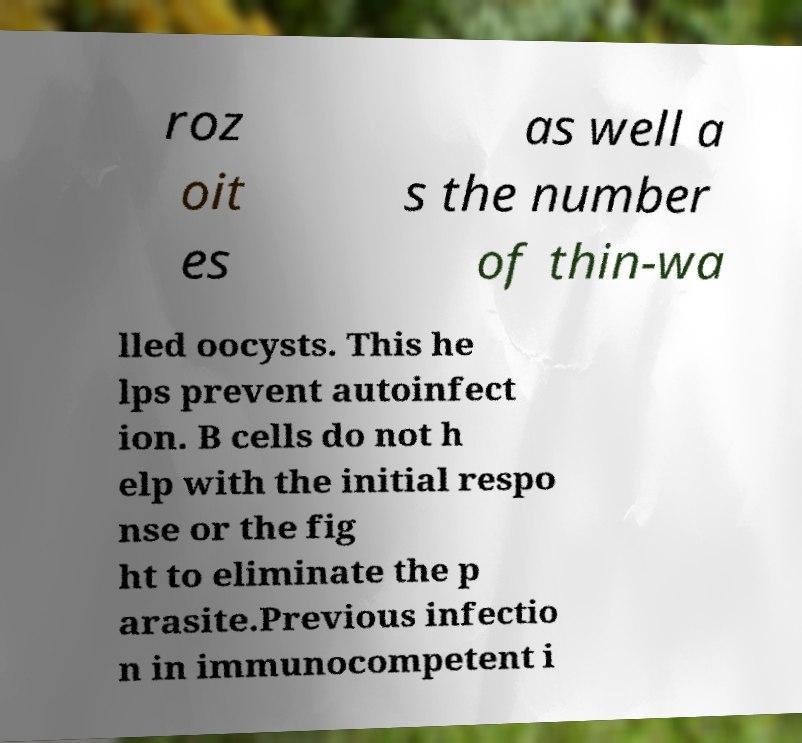I need the written content from this picture converted into text. Can you do that? roz oit es as well a s the number of thin-wa lled oocysts. This he lps prevent autoinfect ion. B cells do not h elp with the initial respo nse or the fig ht to eliminate the p arasite.Previous infectio n in immunocompetent i 